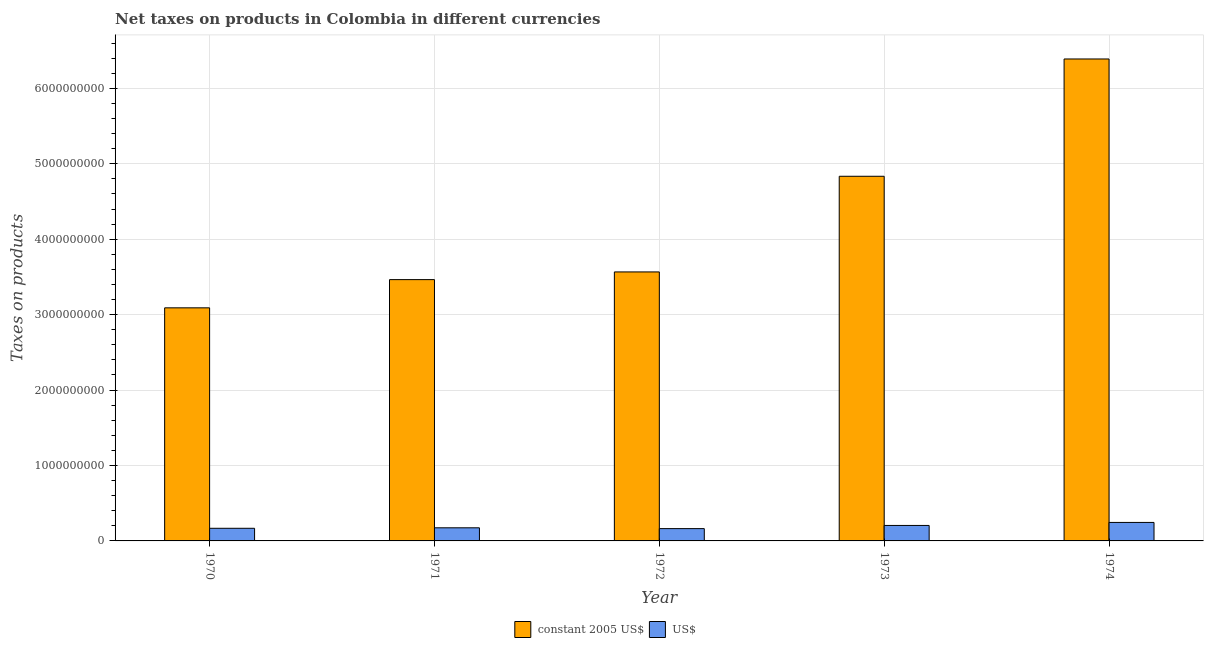How many bars are there on the 1st tick from the left?
Your answer should be very brief. 2. How many bars are there on the 4th tick from the right?
Offer a terse response. 2. In how many cases, is the number of bars for a given year not equal to the number of legend labels?
Provide a succinct answer. 0. What is the net taxes in constant 2005 us$ in 1970?
Your response must be concise. 3.09e+09. Across all years, what is the maximum net taxes in constant 2005 us$?
Ensure brevity in your answer.  6.39e+09. Across all years, what is the minimum net taxes in constant 2005 us$?
Provide a short and direct response. 3.09e+09. In which year was the net taxes in constant 2005 us$ maximum?
Keep it short and to the point. 1974. In which year was the net taxes in constant 2005 us$ minimum?
Offer a terse response. 1970. What is the total net taxes in us$ in the graph?
Give a very brief answer. 9.55e+08. What is the difference between the net taxes in us$ in 1971 and that in 1974?
Your response must be concise. -7.14e+07. What is the difference between the net taxes in constant 2005 us$ in 1971 and the net taxes in us$ in 1972?
Provide a succinct answer. -1.02e+08. What is the average net taxes in us$ per year?
Keep it short and to the point. 1.91e+08. In the year 1973, what is the difference between the net taxes in constant 2005 us$ and net taxes in us$?
Your answer should be compact. 0. In how many years, is the net taxes in constant 2005 us$ greater than 4600000000 units?
Offer a very short reply. 2. What is the ratio of the net taxes in constant 2005 us$ in 1970 to that in 1974?
Your answer should be very brief. 0.48. Is the net taxes in us$ in 1973 less than that in 1974?
Your answer should be compact. Yes. What is the difference between the highest and the second highest net taxes in us$?
Ensure brevity in your answer.  4.01e+07. What is the difference between the highest and the lowest net taxes in us$?
Keep it short and to the point. 8.21e+07. What does the 1st bar from the left in 1972 represents?
Your answer should be compact. Constant 2005 us$. What does the 1st bar from the right in 1971 represents?
Make the answer very short. US$. How many bars are there?
Your answer should be very brief. 10. What is the difference between two consecutive major ticks on the Y-axis?
Your answer should be compact. 1.00e+09. Are the values on the major ticks of Y-axis written in scientific E-notation?
Offer a terse response. No. What is the title of the graph?
Your answer should be very brief. Net taxes on products in Colombia in different currencies. Does "Merchandise imports" appear as one of the legend labels in the graph?
Offer a very short reply. No. What is the label or title of the X-axis?
Your answer should be compact. Year. What is the label or title of the Y-axis?
Offer a very short reply. Taxes on products. What is the Taxes on products in constant 2005 US$ in 1970?
Provide a short and direct response. 3.09e+09. What is the Taxes on products in US$ in 1970?
Give a very brief answer. 1.68e+08. What is the Taxes on products of constant 2005 US$ in 1971?
Give a very brief answer. 3.46e+09. What is the Taxes on products in US$ in 1971?
Offer a very short reply. 1.74e+08. What is the Taxes on products of constant 2005 US$ in 1972?
Provide a succinct answer. 3.57e+09. What is the Taxes on products in US$ in 1972?
Make the answer very short. 1.63e+08. What is the Taxes on products of constant 2005 US$ in 1973?
Provide a short and direct response. 4.83e+09. What is the Taxes on products of US$ in 1973?
Ensure brevity in your answer.  2.05e+08. What is the Taxes on products in constant 2005 US$ in 1974?
Your answer should be compact. 6.39e+09. What is the Taxes on products in US$ in 1974?
Ensure brevity in your answer.  2.45e+08. Across all years, what is the maximum Taxes on products of constant 2005 US$?
Keep it short and to the point. 6.39e+09. Across all years, what is the maximum Taxes on products of US$?
Give a very brief answer. 2.45e+08. Across all years, what is the minimum Taxes on products of constant 2005 US$?
Ensure brevity in your answer.  3.09e+09. Across all years, what is the minimum Taxes on products of US$?
Keep it short and to the point. 1.63e+08. What is the total Taxes on products of constant 2005 US$ in the graph?
Ensure brevity in your answer.  2.13e+1. What is the total Taxes on products in US$ in the graph?
Keep it short and to the point. 9.55e+08. What is the difference between the Taxes on products in constant 2005 US$ in 1970 and that in 1971?
Offer a terse response. -3.74e+08. What is the difference between the Taxes on products of US$ in 1970 and that in 1971?
Provide a short and direct response. -6.25e+06. What is the difference between the Taxes on products in constant 2005 US$ in 1970 and that in 1972?
Your answer should be very brief. -4.76e+08. What is the difference between the Taxes on products of US$ in 1970 and that in 1972?
Provide a short and direct response. 4.45e+06. What is the difference between the Taxes on products in constant 2005 US$ in 1970 and that in 1973?
Keep it short and to the point. -1.74e+09. What is the difference between the Taxes on products of US$ in 1970 and that in 1973?
Give a very brief answer. -3.75e+07. What is the difference between the Taxes on products of constant 2005 US$ in 1970 and that in 1974?
Keep it short and to the point. -3.30e+09. What is the difference between the Taxes on products in US$ in 1970 and that in 1974?
Provide a short and direct response. -7.76e+07. What is the difference between the Taxes on products in constant 2005 US$ in 1971 and that in 1972?
Offer a terse response. -1.02e+08. What is the difference between the Taxes on products in US$ in 1971 and that in 1972?
Make the answer very short. 1.07e+07. What is the difference between the Taxes on products in constant 2005 US$ in 1971 and that in 1973?
Your answer should be compact. -1.37e+09. What is the difference between the Taxes on products of US$ in 1971 and that in 1973?
Your answer should be compact. -3.13e+07. What is the difference between the Taxes on products in constant 2005 US$ in 1971 and that in 1974?
Provide a succinct answer. -2.92e+09. What is the difference between the Taxes on products of US$ in 1971 and that in 1974?
Keep it short and to the point. -7.14e+07. What is the difference between the Taxes on products in constant 2005 US$ in 1972 and that in 1973?
Your answer should be compact. -1.27e+09. What is the difference between the Taxes on products in US$ in 1972 and that in 1973?
Ensure brevity in your answer.  -4.20e+07. What is the difference between the Taxes on products of constant 2005 US$ in 1972 and that in 1974?
Offer a terse response. -2.82e+09. What is the difference between the Taxes on products of US$ in 1972 and that in 1974?
Keep it short and to the point. -8.21e+07. What is the difference between the Taxes on products in constant 2005 US$ in 1973 and that in 1974?
Provide a short and direct response. -1.56e+09. What is the difference between the Taxes on products of US$ in 1973 and that in 1974?
Give a very brief answer. -4.01e+07. What is the difference between the Taxes on products in constant 2005 US$ in 1970 and the Taxes on products in US$ in 1971?
Your answer should be very brief. 2.92e+09. What is the difference between the Taxes on products of constant 2005 US$ in 1970 and the Taxes on products of US$ in 1972?
Make the answer very short. 2.93e+09. What is the difference between the Taxes on products of constant 2005 US$ in 1970 and the Taxes on products of US$ in 1973?
Ensure brevity in your answer.  2.88e+09. What is the difference between the Taxes on products of constant 2005 US$ in 1970 and the Taxes on products of US$ in 1974?
Provide a short and direct response. 2.84e+09. What is the difference between the Taxes on products in constant 2005 US$ in 1971 and the Taxes on products in US$ in 1972?
Give a very brief answer. 3.30e+09. What is the difference between the Taxes on products of constant 2005 US$ in 1971 and the Taxes on products of US$ in 1973?
Your answer should be very brief. 3.26e+09. What is the difference between the Taxes on products in constant 2005 US$ in 1971 and the Taxes on products in US$ in 1974?
Ensure brevity in your answer.  3.22e+09. What is the difference between the Taxes on products of constant 2005 US$ in 1972 and the Taxes on products of US$ in 1973?
Ensure brevity in your answer.  3.36e+09. What is the difference between the Taxes on products in constant 2005 US$ in 1972 and the Taxes on products in US$ in 1974?
Keep it short and to the point. 3.32e+09. What is the difference between the Taxes on products in constant 2005 US$ in 1973 and the Taxes on products in US$ in 1974?
Ensure brevity in your answer.  4.59e+09. What is the average Taxes on products of constant 2005 US$ per year?
Give a very brief answer. 4.27e+09. What is the average Taxes on products of US$ per year?
Make the answer very short. 1.91e+08. In the year 1970, what is the difference between the Taxes on products in constant 2005 US$ and Taxes on products in US$?
Make the answer very short. 2.92e+09. In the year 1971, what is the difference between the Taxes on products of constant 2005 US$ and Taxes on products of US$?
Your answer should be very brief. 3.29e+09. In the year 1972, what is the difference between the Taxes on products of constant 2005 US$ and Taxes on products of US$?
Keep it short and to the point. 3.40e+09. In the year 1973, what is the difference between the Taxes on products of constant 2005 US$ and Taxes on products of US$?
Keep it short and to the point. 4.63e+09. In the year 1974, what is the difference between the Taxes on products in constant 2005 US$ and Taxes on products in US$?
Ensure brevity in your answer.  6.14e+09. What is the ratio of the Taxes on products of constant 2005 US$ in 1970 to that in 1971?
Keep it short and to the point. 0.89. What is the ratio of the Taxes on products of US$ in 1970 to that in 1971?
Your answer should be compact. 0.96. What is the ratio of the Taxes on products in constant 2005 US$ in 1970 to that in 1972?
Provide a succinct answer. 0.87. What is the ratio of the Taxes on products in US$ in 1970 to that in 1972?
Offer a very short reply. 1.03. What is the ratio of the Taxes on products in constant 2005 US$ in 1970 to that in 1973?
Your response must be concise. 0.64. What is the ratio of the Taxes on products in US$ in 1970 to that in 1973?
Offer a very short reply. 0.82. What is the ratio of the Taxes on products of constant 2005 US$ in 1970 to that in 1974?
Your answer should be compact. 0.48. What is the ratio of the Taxes on products in US$ in 1970 to that in 1974?
Provide a succinct answer. 0.68. What is the ratio of the Taxes on products in constant 2005 US$ in 1971 to that in 1972?
Make the answer very short. 0.97. What is the ratio of the Taxes on products in US$ in 1971 to that in 1972?
Make the answer very short. 1.07. What is the ratio of the Taxes on products in constant 2005 US$ in 1971 to that in 1973?
Keep it short and to the point. 0.72. What is the ratio of the Taxes on products in US$ in 1971 to that in 1973?
Make the answer very short. 0.85. What is the ratio of the Taxes on products in constant 2005 US$ in 1971 to that in 1974?
Provide a short and direct response. 0.54. What is the ratio of the Taxes on products in US$ in 1971 to that in 1974?
Give a very brief answer. 0.71. What is the ratio of the Taxes on products in constant 2005 US$ in 1972 to that in 1973?
Make the answer very short. 0.74. What is the ratio of the Taxes on products in US$ in 1972 to that in 1973?
Ensure brevity in your answer.  0.8. What is the ratio of the Taxes on products of constant 2005 US$ in 1972 to that in 1974?
Provide a short and direct response. 0.56. What is the ratio of the Taxes on products of US$ in 1972 to that in 1974?
Offer a terse response. 0.67. What is the ratio of the Taxes on products in constant 2005 US$ in 1973 to that in 1974?
Give a very brief answer. 0.76. What is the ratio of the Taxes on products of US$ in 1973 to that in 1974?
Keep it short and to the point. 0.84. What is the difference between the highest and the second highest Taxes on products in constant 2005 US$?
Provide a short and direct response. 1.56e+09. What is the difference between the highest and the second highest Taxes on products in US$?
Keep it short and to the point. 4.01e+07. What is the difference between the highest and the lowest Taxes on products in constant 2005 US$?
Give a very brief answer. 3.30e+09. What is the difference between the highest and the lowest Taxes on products in US$?
Your response must be concise. 8.21e+07. 